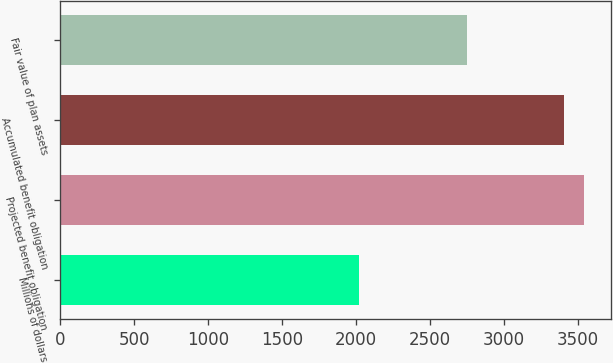Convert chart. <chart><loc_0><loc_0><loc_500><loc_500><bar_chart><fcel>Millions of dollars<fcel>Projected benefit obligation<fcel>Accumulated benefit obligation<fcel>Fair value of plan assets<nl><fcel>2017<fcel>3542.8<fcel>3403<fcel>2746<nl></chart> 